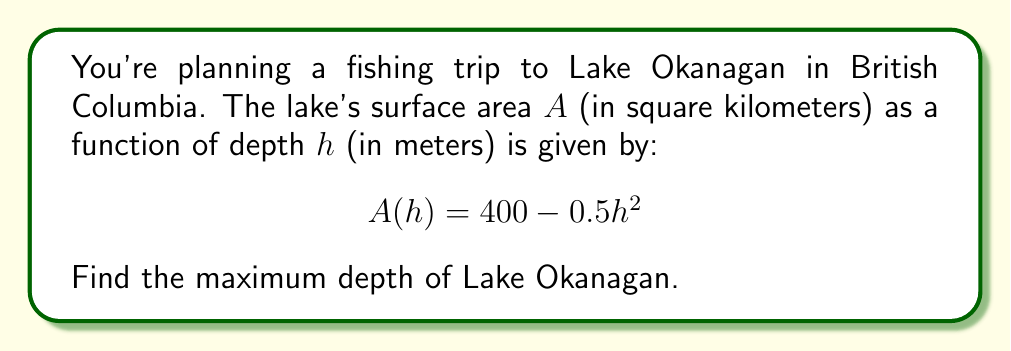Teach me how to tackle this problem. To find the maximum depth of the lake, we need to determine the depth at which the surface area becomes zero. This is because the lake's surface area decreases as we go deeper until it reaches zero at the deepest point.

Step 1: Set up the equation
We want to find $h$ when $A(h) = 0$:
$$0 = 400 - 0.5h^2$$

Step 2: Solve for $h$
$$0.5h^2 = 400$$
$$h^2 = 800$$
$$h = \pm\sqrt{800}$$

Step 3: Interpret the result
Since depth cannot be negative, we only consider the positive solution:
$$h = \sqrt{800} = 20\sqrt{2} \approx 28.28$$

Therefore, the maximum depth of Lake Okanagan is approximately 28.28 meters.
Answer: $20\sqrt{2}$ meters 